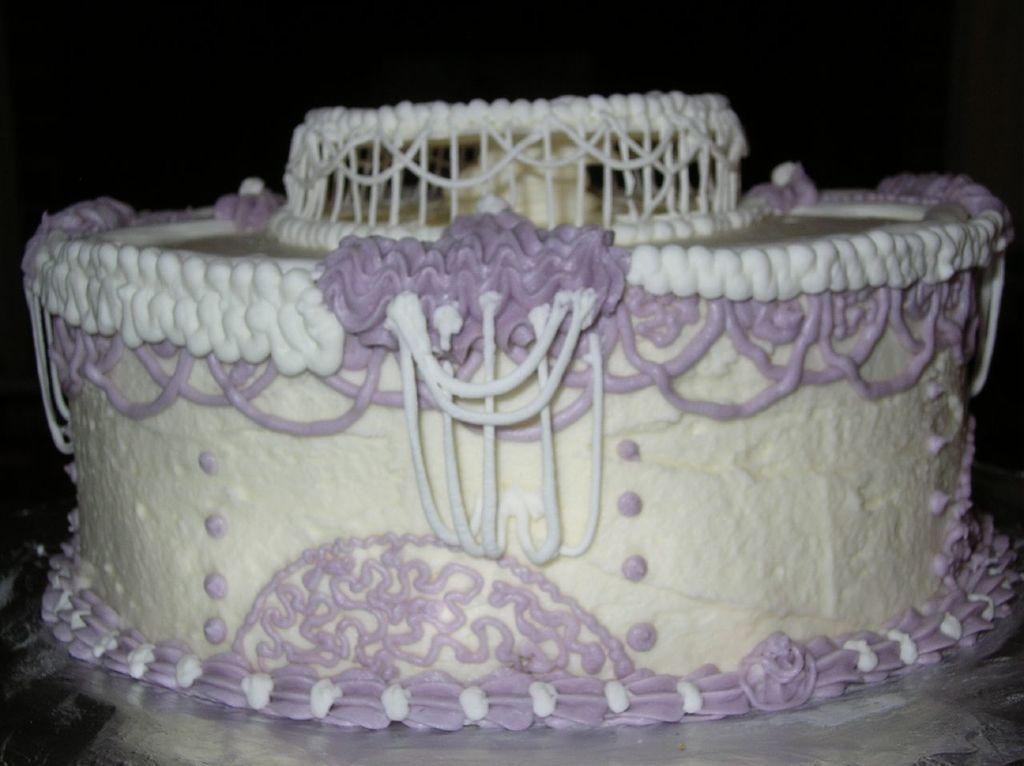How would you summarize this image in a sentence or two? In this picture we can see a cake on a platform and in the background we can see it is dark. 